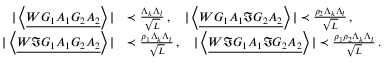Convert formula to latex. <formula><loc_0><loc_0><loc_500><loc_500>\begin{array} { r l } { | \left \langle { \underline { { W G _ { 1 } A _ { 1 } G _ { 2 } A _ { 2 } } } } \right \rangle | } & { \prec \frac { \Lambda _ { k } \Lambda _ { l } } { \sqrt { L } } \, , \quad | \left \langle { \underline { { W G _ { 1 } A _ { 1 } \Im G _ { 2 } A _ { 2 } } } } \right \rangle | \prec \frac { \rho _ { 2 } \Lambda _ { k } \Lambda _ { l } } { \sqrt { L } } \, , } \\ { | \left \langle { \underline { { W \Im G _ { 1 } A _ { 1 } G _ { 2 } A _ { 2 } } } } \right \rangle | } & { \prec \frac { \rho _ { 1 } \Lambda _ { k } \Lambda _ { l } } { \sqrt { L } } \, , \quad | \left \langle { \underline { { W \Im G _ { 1 } A _ { 1 } \Im G _ { 2 } A _ { 2 } } } } \right \rangle | \prec \frac { \rho _ { 1 } \rho _ { 2 } \Lambda _ { k } \Lambda _ { l } } { \sqrt { L } } \, . } \end{array}</formula> 